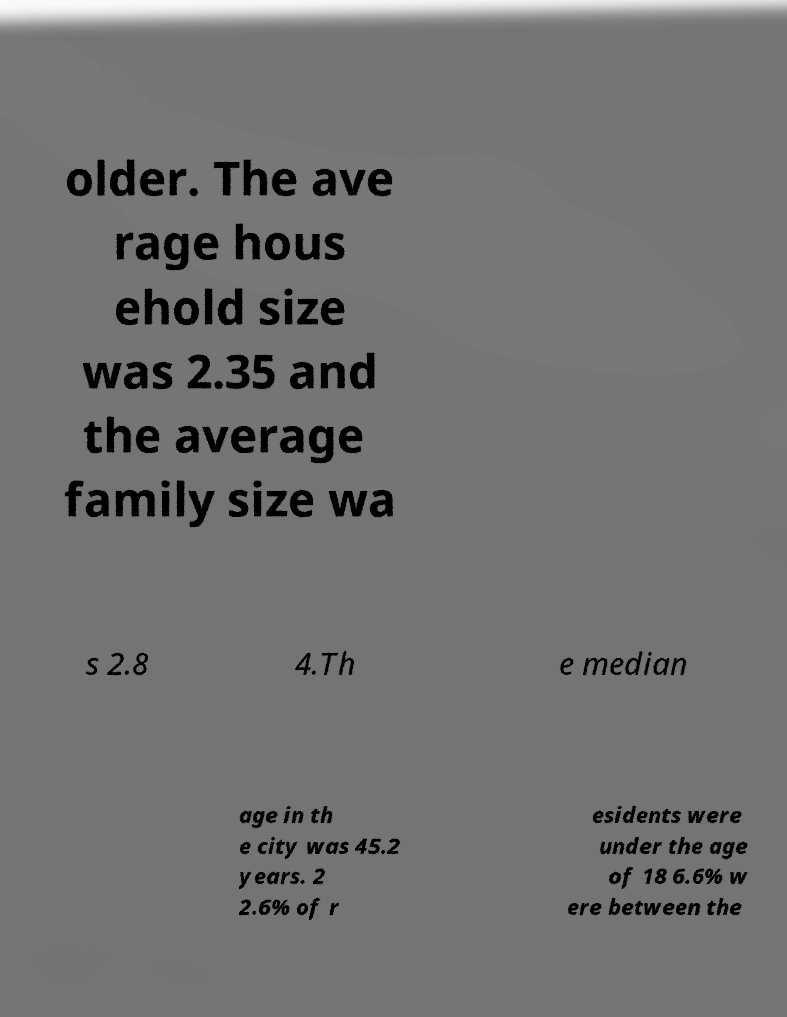Please identify and transcribe the text found in this image. older. The ave rage hous ehold size was 2.35 and the average family size wa s 2.8 4.Th e median age in th e city was 45.2 years. 2 2.6% of r esidents were under the age of 18 6.6% w ere between the 